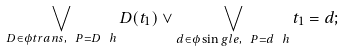Convert formula to latex. <formula><loc_0><loc_0><loc_500><loc_500>\bigvee _ { D \in \phi t r a n s , \ P = D ^ { \ } h } D ( t _ { 1 } ) \vee \bigvee _ { d \in \phi \sin g l e , \ P = d ^ { \ } h } t _ { 1 } = d ;</formula> 